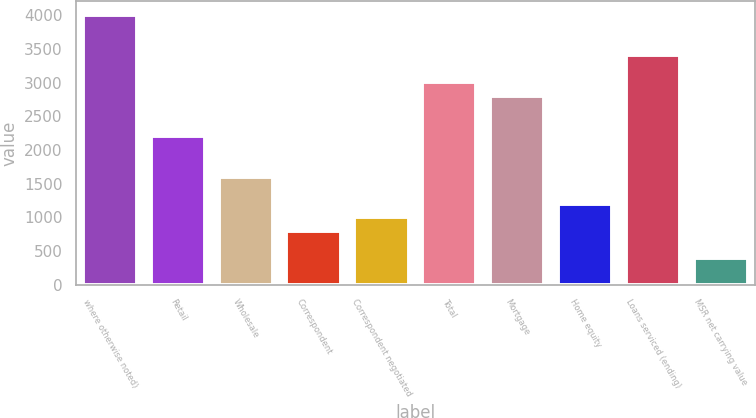<chart> <loc_0><loc_0><loc_500><loc_500><bar_chart><fcel>where otherwise noted)<fcel>Retail<fcel>Wholesale<fcel>Correspondent<fcel>Correspondent negotiated<fcel>Total<fcel>Mortgage<fcel>Home equity<fcel>Loans serviced (ending)<fcel>MSR net carrying value<nl><fcel>4007.37<fcel>2204.36<fcel>1603.35<fcel>802<fcel>1002.34<fcel>3005.7<fcel>2805.37<fcel>1202.67<fcel>3406.37<fcel>401.33<nl></chart> 